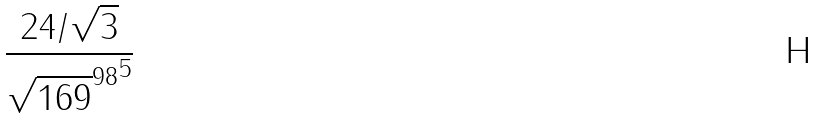<formula> <loc_0><loc_0><loc_500><loc_500>\frac { 2 4 / \sqrt { 3 } } { { \sqrt { 1 6 9 } ^ { 9 8 } } ^ { 5 } }</formula> 